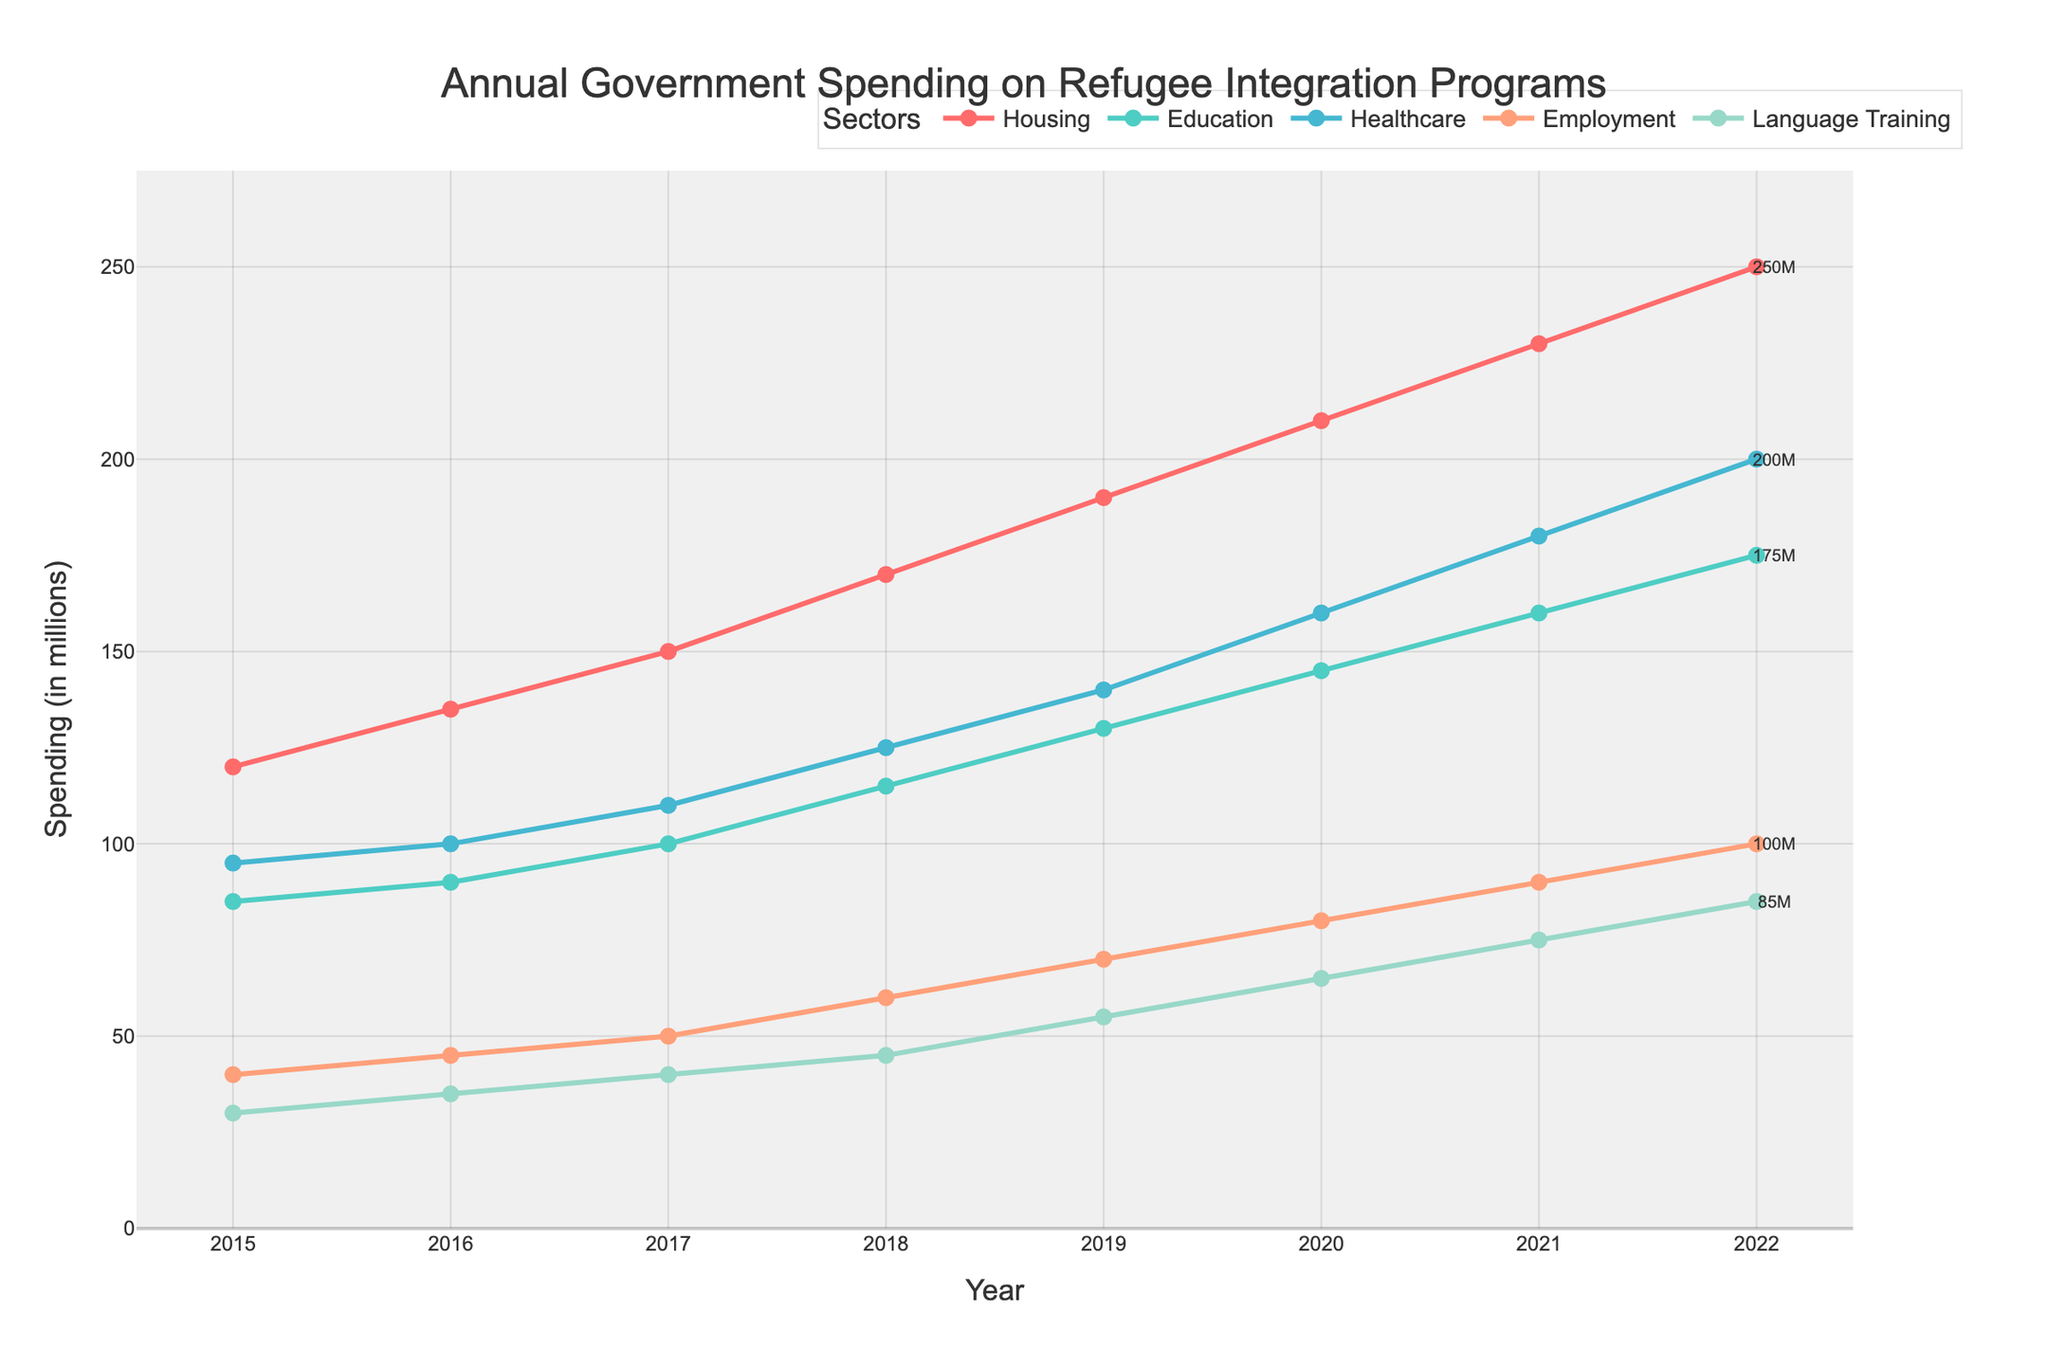What's the trend shown in the government spending on housing from 2015 to 2022? To answer this, look at the line representing housing expenditures. From 2015 to 2022, the spending on housing increased every year.
Answer: Increasing Which sector had the highest spending in 2022? Check the ending values of all the lines for the year 2022. The sector with the highest spending is housing, which ends at 250 million.
Answer: Housing How much more was spent on healthcare compared to education in 2020? In 2020, healthcare spending was 160 million and education spending was 145 million. Calculate the difference: 160 - 145 = 15.
Answer: 15 million Which sectors saw a consistent increase in spending over the years without any decrease? By observing all the lines, we see that housing, education, healthcare, employment, and language training all had a continuous upward trend from 2015 to 2022 without any dips.
Answer: Housing, Education, Healthcare, Employment, Language Training What was the average annual spending on language training from 2015 to 2022? Add the values from 2015 to 2022 for language training: 30 + 35 + 40 + 45 + 55 + 65 + 75 + 85 = 430. Then, divide by the number of years: 430 / 8 = 53.75.
Answer: 53.75 million In which year did employment sector spending reach 70 million? Find the point where the employment sector line reaches 70 million. According to the chart, this occurred in 2019.
Answer: 2019 What's the total spending on refugee integration programs in 2018 across all sectors? Sum the spending for each sector in 2018: 170 (housing) + 115 (education) + 125 (healthcare) + 60 (employment) + 45 (language training) = 515.
Answer: 515 million Compare the rate of increase in spending on healthcare and education from 2015 to 2022. Which increased at a higher rate? Calculate the difference in spending from 2015 to 2022 for both sectors. Healthcare: 200 - 95 = 105. Education: 175 - 85 = 90. The rate of increase is higher for healthcare (105 million) compared to education (90 million).
Answer: Healthcare How does the government spending on housing in 2022 compare to that in 2015? Compare the 2022 value to the 2015 value for housing. In 2022, it was 250 million, and in 2015, it was 120 million. Thus, the spending more than doubled.
Answer: More than doubled By what percentage did the spending on language training grow from 2015 to 2022? First, find the change in spending: 85 (2022) - 30 (2015) = 55. Then, divide by the 2015 value and multiply by 100 to convert to a percentage: (55 / 30) * 100 ≈ 183.33%.
Answer: 183.33% 